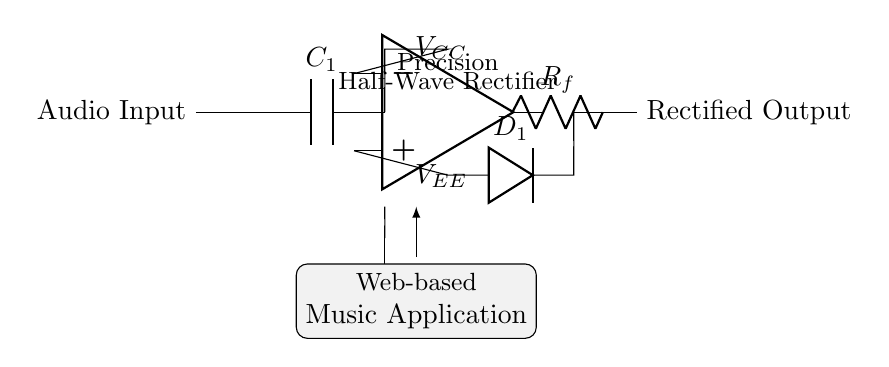What is the type of rectifier shown in the circuit? The circuit diagram indicates a half-wave rectifier, evidenced by the placement of the diode which allows only one half of the input signal to pass through.
Answer: Half-wave What component is used to smooth the input audio signal? The capacitor labeled C1 is responsible for smoothing the input audio signal by charging and discharging, reducing voltage fluctuations.
Answer: Capacitor Which component performs the rectification in this circuit? The diode labeled D1 allows current to flow in only one direction, effectively converting the AC input signal into a pulsed DC output, which is the purpose of rectification.
Answer: Diode What is the output from this rectifier circuit? The output is referred to as the rectified output, which is the processed audio signal after rectification has occurred through D1.
Answer: Rectified output What are the power supply voltages provided to the op-amp? The op-amp is supplied with positive and negative voltages, labeled VCC and VEE in the circuit, to function properly for signal amplification and processing.
Answer: VCC and VEE What role does the feedback resistor play in this circuit? The feedback resistor labeled Rf creates a negative feedback loop that stabilizes the gain of the op-amp, ensuring accurate amplification of the audio signal.
Answer: Feedback How is this circuit contextually linked to web-based music applications? The circuit is placed within a shaded box that indicates its application within a web-based music application, highlighting its purpose in processing audio signals for such platforms.
Answer: Web-based music application 